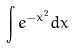Convert formula to latex. <formula><loc_0><loc_0><loc_500><loc_500>\int e ^ { - x ^ { 2 } } d x</formula> 